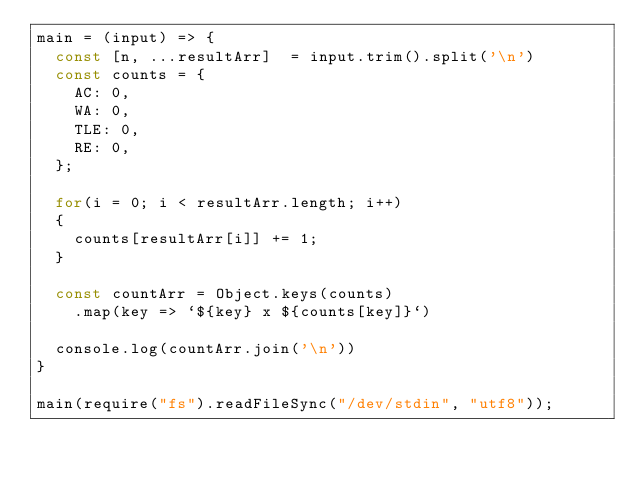Convert code to text. <code><loc_0><loc_0><loc_500><loc_500><_JavaScript_>main = (input) => {
  const [n, ...resultArr]  = input.trim().split('\n')
  const counts = {
    AC: 0,
    WA: 0,
    TLE: 0,
    RE: 0,
  };

  for(i = 0; i < resultArr.length; i++)
  {
    counts[resultArr[i]] += 1;
  }
  
  const countArr = Object.keys(counts)
    .map(key => `${key} x ${counts[key]}`)
  
  console.log(countArr.join('\n'))
}

main(require("fs").readFileSync("/dev/stdin", "utf8"));</code> 